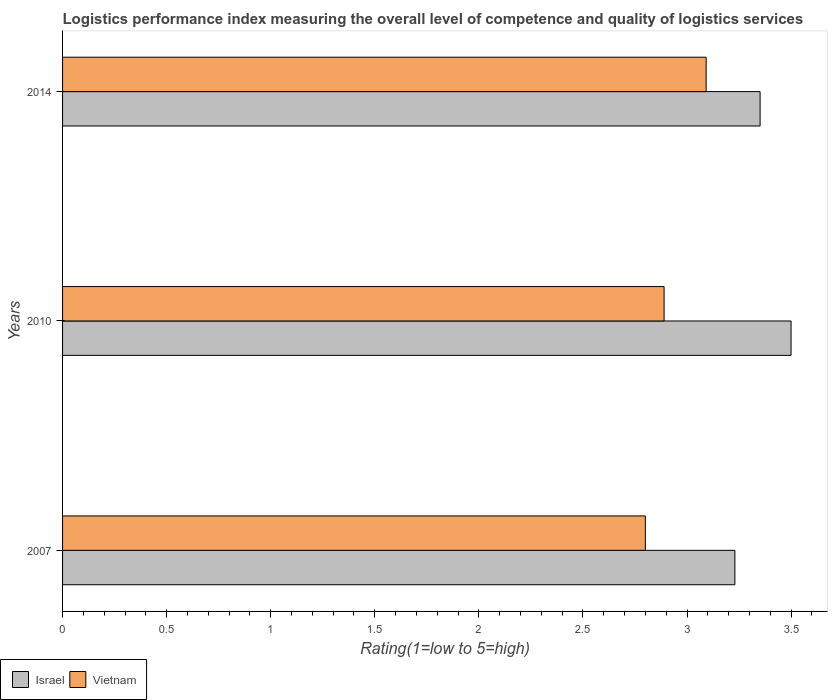How many different coloured bars are there?
Give a very brief answer. 2. How many groups of bars are there?
Make the answer very short. 3. Are the number of bars per tick equal to the number of legend labels?
Ensure brevity in your answer.  Yes. How many bars are there on the 1st tick from the top?
Offer a very short reply. 2. How many bars are there on the 2nd tick from the bottom?
Provide a succinct answer. 2. What is the label of the 2nd group of bars from the top?
Ensure brevity in your answer.  2010. In how many cases, is the number of bars for a given year not equal to the number of legend labels?
Your response must be concise. 0. Across all years, what is the maximum Logistic performance index in Vietnam?
Offer a very short reply. 3.09. Across all years, what is the minimum Logistic performance index in Israel?
Keep it short and to the point. 3.23. In which year was the Logistic performance index in Israel minimum?
Provide a short and direct response. 2007. What is the total Logistic performance index in Israel in the graph?
Your answer should be very brief. 10.08. What is the difference between the Logistic performance index in Israel in 2010 and that in 2014?
Make the answer very short. 0.15. What is the difference between the Logistic performance index in Israel in 2010 and the Logistic performance index in Vietnam in 2014?
Make the answer very short. 0.41. What is the average Logistic performance index in Vietnam per year?
Provide a succinct answer. 2.93. In the year 2010, what is the difference between the Logistic performance index in Israel and Logistic performance index in Vietnam?
Provide a short and direct response. 0.61. What is the ratio of the Logistic performance index in Israel in 2010 to that in 2014?
Ensure brevity in your answer.  1.04. Is the Logistic performance index in Israel in 2010 less than that in 2014?
Your answer should be compact. No. Is the difference between the Logistic performance index in Israel in 2010 and 2014 greater than the difference between the Logistic performance index in Vietnam in 2010 and 2014?
Provide a short and direct response. Yes. What is the difference between the highest and the second highest Logistic performance index in Vietnam?
Provide a short and direct response. 0.2. What is the difference between the highest and the lowest Logistic performance index in Israel?
Your answer should be very brief. 0.27. How many years are there in the graph?
Offer a terse response. 3. What is the difference between two consecutive major ticks on the X-axis?
Offer a terse response. 0.5. Are the values on the major ticks of X-axis written in scientific E-notation?
Your response must be concise. No. Does the graph contain any zero values?
Offer a very short reply. No. Does the graph contain grids?
Your answer should be compact. No. How many legend labels are there?
Offer a terse response. 2. How are the legend labels stacked?
Offer a very short reply. Horizontal. What is the title of the graph?
Your answer should be compact. Logistics performance index measuring the overall level of competence and quality of logistics services. Does "United States" appear as one of the legend labels in the graph?
Your answer should be compact. No. What is the label or title of the X-axis?
Provide a succinct answer. Rating(1=low to 5=high). What is the label or title of the Y-axis?
Provide a succinct answer. Years. What is the Rating(1=low to 5=high) in Israel in 2007?
Provide a short and direct response. 3.23. What is the Rating(1=low to 5=high) in Vietnam in 2007?
Your response must be concise. 2.8. What is the Rating(1=low to 5=high) in Israel in 2010?
Your answer should be very brief. 3.5. What is the Rating(1=low to 5=high) in Vietnam in 2010?
Keep it short and to the point. 2.89. What is the Rating(1=low to 5=high) of Israel in 2014?
Provide a succinct answer. 3.35. What is the Rating(1=low to 5=high) of Vietnam in 2014?
Give a very brief answer. 3.09. Across all years, what is the maximum Rating(1=low to 5=high) of Vietnam?
Provide a succinct answer. 3.09. Across all years, what is the minimum Rating(1=low to 5=high) of Israel?
Provide a short and direct response. 3.23. What is the total Rating(1=low to 5=high) of Israel in the graph?
Make the answer very short. 10.08. What is the total Rating(1=low to 5=high) of Vietnam in the graph?
Your answer should be compact. 8.78. What is the difference between the Rating(1=low to 5=high) of Israel in 2007 and that in 2010?
Keep it short and to the point. -0.27. What is the difference between the Rating(1=low to 5=high) of Vietnam in 2007 and that in 2010?
Give a very brief answer. -0.09. What is the difference between the Rating(1=low to 5=high) of Israel in 2007 and that in 2014?
Offer a very short reply. -0.12. What is the difference between the Rating(1=low to 5=high) of Vietnam in 2007 and that in 2014?
Your answer should be compact. -0.29. What is the difference between the Rating(1=low to 5=high) in Israel in 2010 and that in 2014?
Offer a very short reply. 0.15. What is the difference between the Rating(1=low to 5=high) of Vietnam in 2010 and that in 2014?
Provide a short and direct response. -0.2. What is the difference between the Rating(1=low to 5=high) in Israel in 2007 and the Rating(1=low to 5=high) in Vietnam in 2010?
Give a very brief answer. 0.34. What is the difference between the Rating(1=low to 5=high) of Israel in 2007 and the Rating(1=low to 5=high) of Vietnam in 2014?
Your answer should be compact. 0.14. What is the difference between the Rating(1=low to 5=high) of Israel in 2010 and the Rating(1=low to 5=high) of Vietnam in 2014?
Ensure brevity in your answer.  0.41. What is the average Rating(1=low to 5=high) in Israel per year?
Your response must be concise. 3.36. What is the average Rating(1=low to 5=high) in Vietnam per year?
Provide a short and direct response. 2.93. In the year 2007, what is the difference between the Rating(1=low to 5=high) of Israel and Rating(1=low to 5=high) of Vietnam?
Provide a succinct answer. 0.43. In the year 2010, what is the difference between the Rating(1=low to 5=high) of Israel and Rating(1=low to 5=high) of Vietnam?
Offer a very short reply. 0.61. In the year 2014, what is the difference between the Rating(1=low to 5=high) in Israel and Rating(1=low to 5=high) in Vietnam?
Provide a succinct answer. 0.26. What is the ratio of the Rating(1=low to 5=high) of Israel in 2007 to that in 2010?
Offer a very short reply. 0.92. What is the ratio of the Rating(1=low to 5=high) of Vietnam in 2007 to that in 2010?
Give a very brief answer. 0.97. What is the ratio of the Rating(1=low to 5=high) in Israel in 2007 to that in 2014?
Make the answer very short. 0.96. What is the ratio of the Rating(1=low to 5=high) in Vietnam in 2007 to that in 2014?
Offer a very short reply. 0.91. What is the ratio of the Rating(1=low to 5=high) in Israel in 2010 to that in 2014?
Give a very brief answer. 1.04. What is the ratio of the Rating(1=low to 5=high) in Vietnam in 2010 to that in 2014?
Ensure brevity in your answer.  0.93. What is the difference between the highest and the second highest Rating(1=low to 5=high) of Israel?
Give a very brief answer. 0.15. What is the difference between the highest and the second highest Rating(1=low to 5=high) in Vietnam?
Your response must be concise. 0.2. What is the difference between the highest and the lowest Rating(1=low to 5=high) of Israel?
Give a very brief answer. 0.27. What is the difference between the highest and the lowest Rating(1=low to 5=high) in Vietnam?
Your response must be concise. 0.29. 